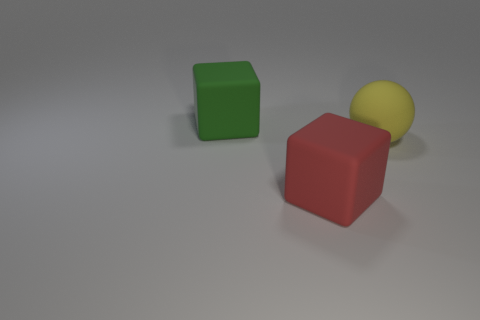Add 3 tiny yellow metallic cylinders. How many objects exist? 6 Subtract all blocks. How many objects are left? 1 Subtract all large green rubber things. Subtract all big yellow objects. How many objects are left? 1 Add 1 green matte objects. How many green matte objects are left? 2 Add 1 rubber cubes. How many rubber cubes exist? 3 Subtract 0 cyan balls. How many objects are left? 3 